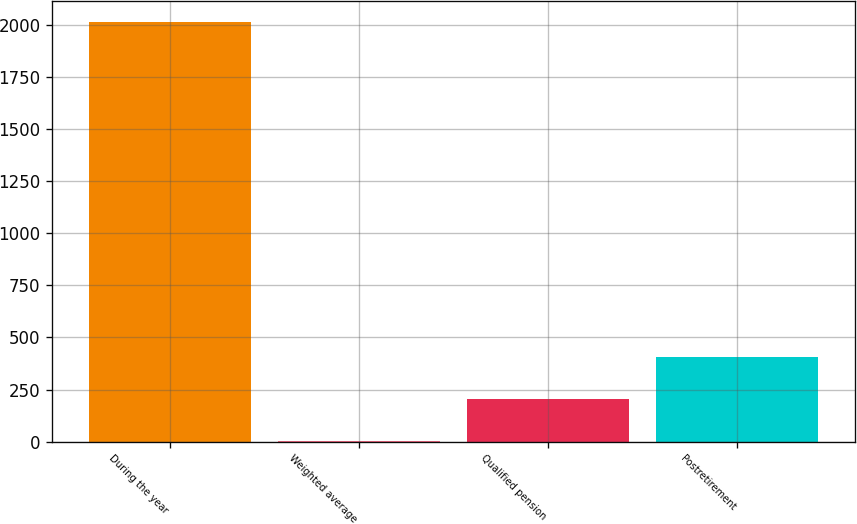Convert chart. <chart><loc_0><loc_0><loc_500><loc_500><bar_chart><fcel>During the year<fcel>Weighted average<fcel>Qualified pension<fcel>Postretirement<nl><fcel>2015<fcel>4.74<fcel>205.77<fcel>406.8<nl></chart> 